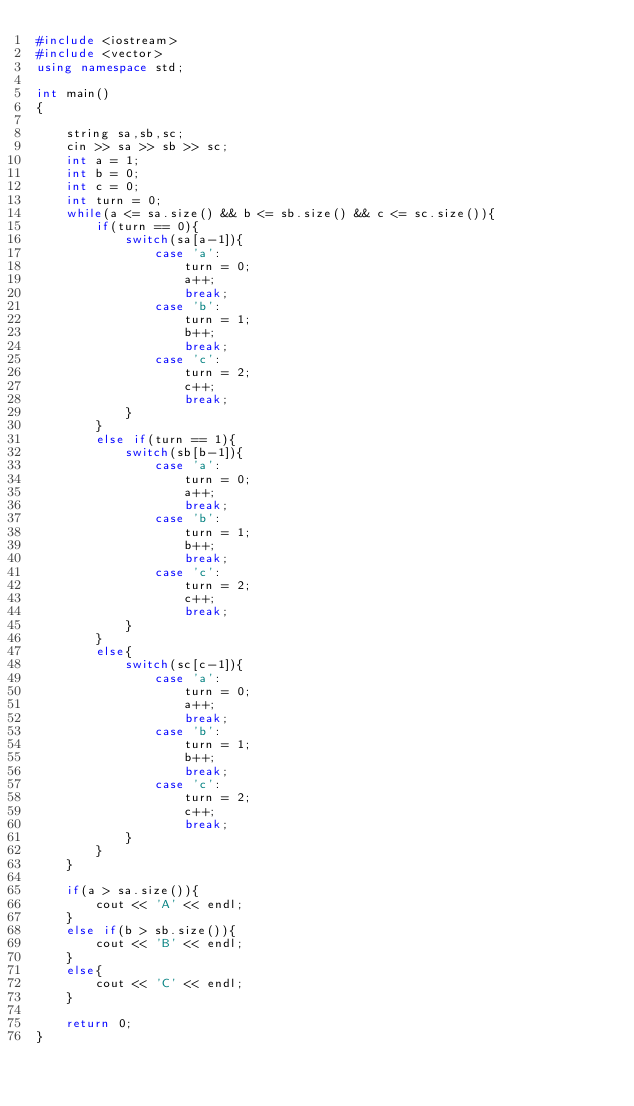<code> <loc_0><loc_0><loc_500><loc_500><_C++_>#include <iostream>
#include <vector>
using namespace std;

int main()
{
    
    string sa,sb,sc;
    cin >> sa >> sb >> sc;
    int a = 1;
    int b = 0;
    int c = 0;
    int turn = 0;
    while(a <= sa.size() && b <= sb.size() && c <= sc.size()){
        if(turn == 0){
            switch(sa[a-1]){
                case 'a':
                    turn = 0;
                    a++;
                    break;
                case 'b':
                    turn = 1;
                    b++;
                    break;
                case 'c':
                    turn = 2;
                    c++;
                    break;
            }
        }
        else if(turn == 1){
            switch(sb[b-1]){
                case 'a':
                    turn = 0;
                    a++;
                    break;
                case 'b':
                    turn = 1;
                    b++;
                    break;
                case 'c':
                    turn = 2;
                    c++;
                    break;
            }
        }
        else{
            switch(sc[c-1]){
                case 'a':
                    turn = 0;
                    a++;
                    break;
                case 'b':
                    turn = 1;
                    b++;
                    break;
                case 'c':
                    turn = 2;
                    c++;
                    break;
            }
        }
    }

    if(a > sa.size()){
        cout << 'A' << endl;
    }
    else if(b > sb.size()){
        cout << 'B' << endl;
    }
    else{
        cout << 'C' << endl;
    }

    return 0;
}</code> 